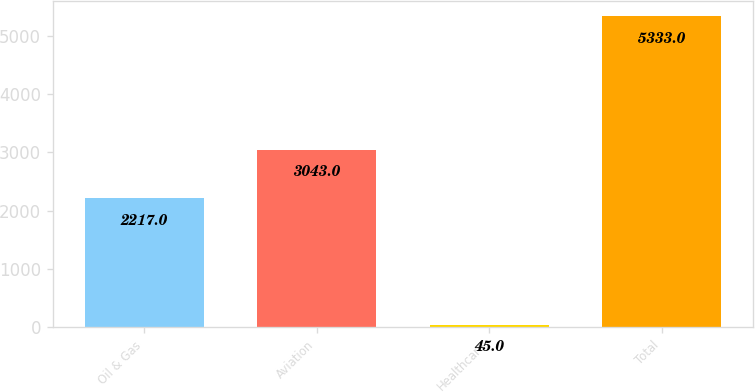Convert chart. <chart><loc_0><loc_0><loc_500><loc_500><bar_chart><fcel>Oil & Gas<fcel>Aviation<fcel>Healthcare<fcel>Total<nl><fcel>2217<fcel>3043<fcel>45<fcel>5333<nl></chart> 